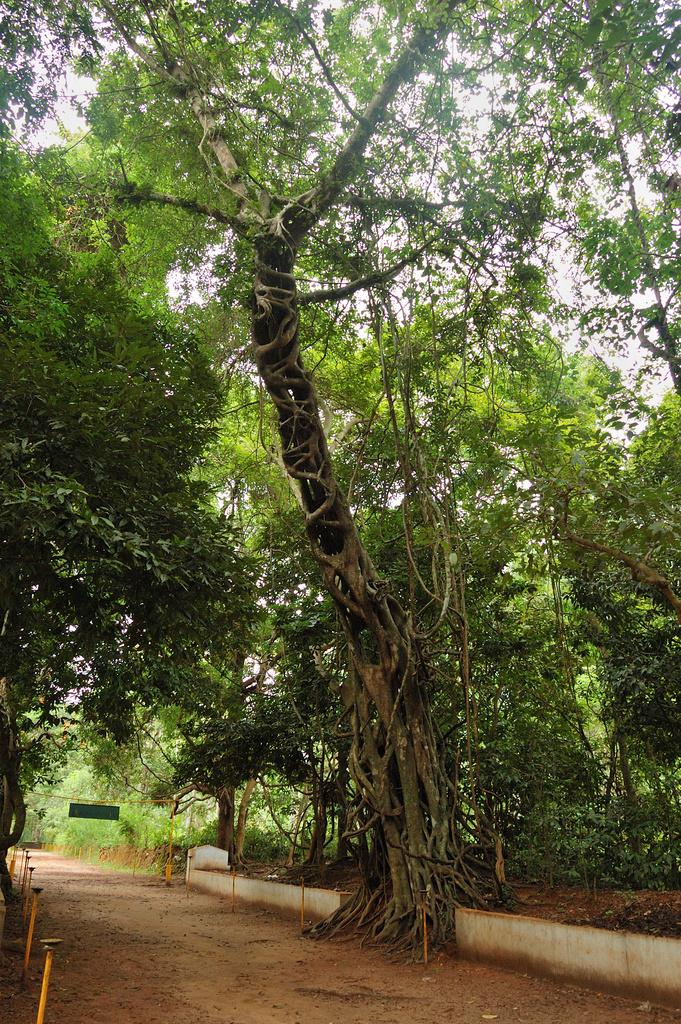What type of vegetation is present in the image? There are trees in the image. What object can be seen in the image that might be used for displaying information or messages? There is a board in the image. What structures are present at the bottom of the image? There are poles at the bottom of the image. What type of man-made structure is visible in the image? There is a wall visible in the image. How many ants can be seen crawling on the board in the image? There are no ants present in the image. What type of material is the sheet covering the trees in the image? There is no sheet covering the trees in the image. 